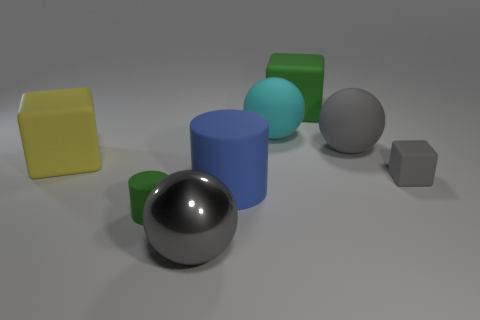What is the material of the gray thing that is behind the green cylinder and on the left side of the tiny gray matte thing?
Give a very brief answer. Rubber. Are any small gray shiny cylinders visible?
Your answer should be compact. No. There is a blue object that is made of the same material as the green cylinder; what is its shape?
Offer a very short reply. Cylinder. Do the cyan matte object and the big green rubber object that is behind the tiny gray thing have the same shape?
Make the answer very short. No. The green thing that is behind the cylinder to the left of the gray shiny object is made of what material?
Offer a terse response. Rubber. What number of other objects are there of the same shape as the large yellow rubber object?
Ensure brevity in your answer.  2. There is a blue rubber object on the right side of the large gray metallic ball; is it the same shape as the green thing to the left of the large blue matte cylinder?
Your response must be concise. Yes. Are there any other things that have the same material as the tiny gray block?
Give a very brief answer. Yes. What is the small green object made of?
Offer a very short reply. Rubber. What material is the big block that is behind the big cyan rubber object?
Ensure brevity in your answer.  Rubber. 